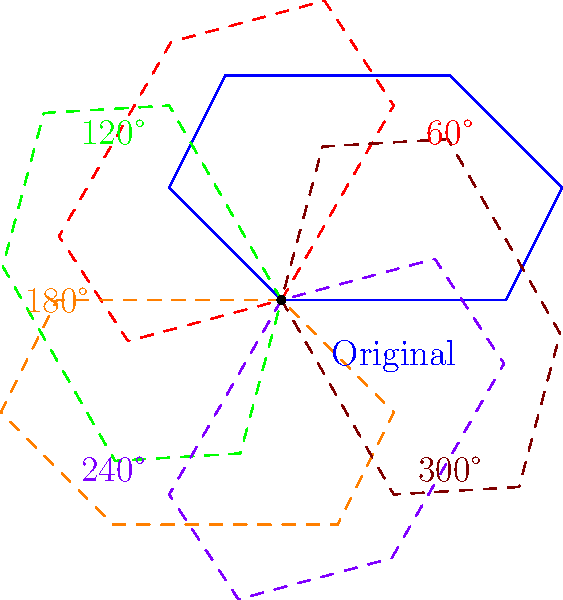As a local reporter covering traditional Maltese boats, you've learned about the symmetry of the luzzu. If a luzzu has rotational symmetry as shown in the diagram, what is the order of the dihedral group $D_n$ that describes its symmetries? To determine the order of the dihedral group $D_n$ for the luzzu, we need to follow these steps:

1. Observe the rotational symmetries in the diagram:
   The luzzu is shown with 6 different orientations, including the original position.

2. Count the number of distinct rotations:
   There are 6 rotations (0°, 60°, 120°, 180°, 240°, 300°).

3. Identify the value of $n$:
   The number of rotations is equal to $n$ in the dihedral group $D_n$. So, $n = 6$.

4. Calculate the order of the dihedral group:
   For a dihedral group $D_n$, the order is given by $|D_n| = 2n$.
   In this case, $|D_6| = 2 \cdot 6 = 12$.

Therefore, the order of the dihedral group describing the symmetries of the luzzu is 12.
Answer: 12 